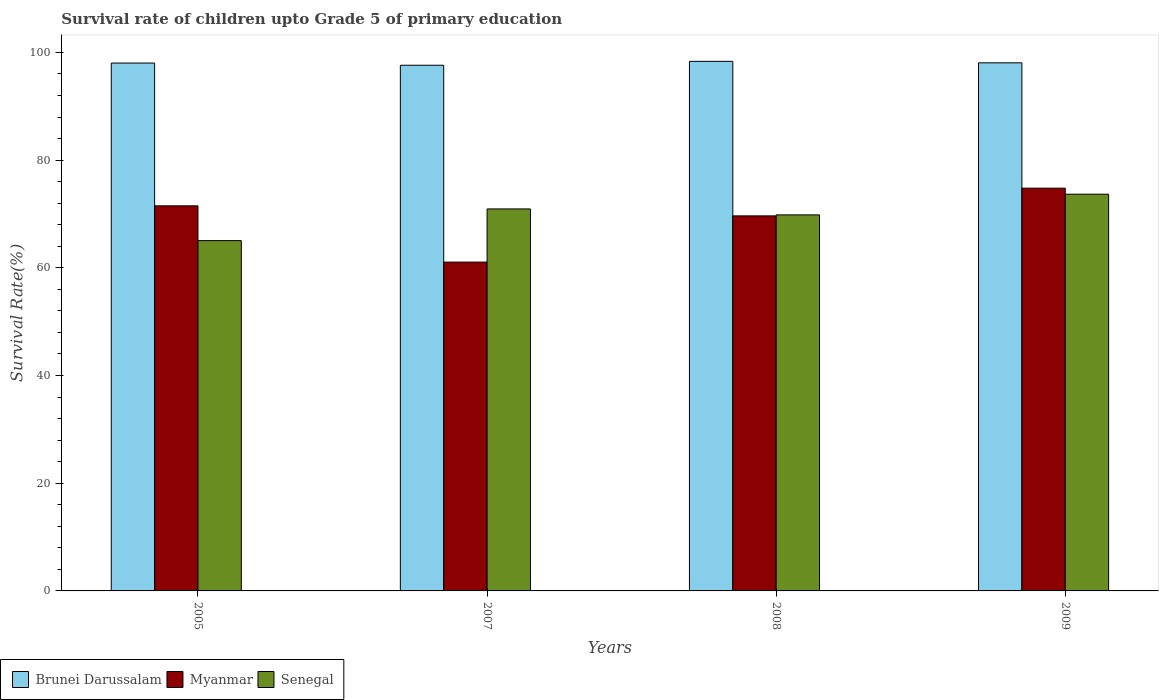How many groups of bars are there?
Offer a very short reply. 4. Are the number of bars per tick equal to the number of legend labels?
Offer a terse response. Yes. Are the number of bars on each tick of the X-axis equal?
Offer a very short reply. Yes. How many bars are there on the 2nd tick from the right?
Your answer should be very brief. 3. What is the label of the 1st group of bars from the left?
Offer a very short reply. 2005. What is the survival rate of children in Brunei Darussalam in 2007?
Ensure brevity in your answer.  97.62. Across all years, what is the maximum survival rate of children in Myanmar?
Ensure brevity in your answer.  74.79. Across all years, what is the minimum survival rate of children in Myanmar?
Make the answer very short. 61.06. In which year was the survival rate of children in Senegal maximum?
Provide a succinct answer. 2009. What is the total survival rate of children in Myanmar in the graph?
Keep it short and to the point. 277.01. What is the difference between the survival rate of children in Myanmar in 2008 and that in 2009?
Your response must be concise. -5.15. What is the difference between the survival rate of children in Brunei Darussalam in 2007 and the survival rate of children in Myanmar in 2005?
Provide a short and direct response. 26.11. What is the average survival rate of children in Senegal per year?
Provide a short and direct response. 69.87. In the year 2005, what is the difference between the survival rate of children in Senegal and survival rate of children in Myanmar?
Ensure brevity in your answer.  -6.46. In how many years, is the survival rate of children in Myanmar greater than 40 %?
Offer a terse response. 4. What is the ratio of the survival rate of children in Myanmar in 2007 to that in 2008?
Make the answer very short. 0.88. Is the survival rate of children in Myanmar in 2008 less than that in 2009?
Provide a short and direct response. Yes. What is the difference between the highest and the second highest survival rate of children in Brunei Darussalam?
Ensure brevity in your answer.  0.27. What is the difference between the highest and the lowest survival rate of children in Senegal?
Provide a short and direct response. 8.62. Is the sum of the survival rate of children in Brunei Darussalam in 2005 and 2009 greater than the maximum survival rate of children in Myanmar across all years?
Offer a very short reply. Yes. What does the 1st bar from the left in 2007 represents?
Provide a short and direct response. Brunei Darussalam. What does the 2nd bar from the right in 2008 represents?
Your answer should be very brief. Myanmar. Does the graph contain any zero values?
Provide a succinct answer. No. Does the graph contain grids?
Your answer should be compact. No. How are the legend labels stacked?
Provide a short and direct response. Horizontal. What is the title of the graph?
Keep it short and to the point. Survival rate of children upto Grade 5 of primary education. Does "Northern Mariana Islands" appear as one of the legend labels in the graph?
Your answer should be very brief. No. What is the label or title of the Y-axis?
Your answer should be compact. Survival Rate(%). What is the Survival Rate(%) of Brunei Darussalam in 2005?
Provide a succinct answer. 98.03. What is the Survival Rate(%) in Myanmar in 2005?
Provide a succinct answer. 71.51. What is the Survival Rate(%) in Senegal in 2005?
Keep it short and to the point. 65.05. What is the Survival Rate(%) of Brunei Darussalam in 2007?
Your answer should be very brief. 97.62. What is the Survival Rate(%) in Myanmar in 2007?
Your answer should be compact. 61.06. What is the Survival Rate(%) of Senegal in 2007?
Make the answer very short. 70.94. What is the Survival Rate(%) in Brunei Darussalam in 2008?
Your answer should be compact. 98.34. What is the Survival Rate(%) in Myanmar in 2008?
Ensure brevity in your answer.  69.65. What is the Survival Rate(%) in Senegal in 2008?
Offer a terse response. 69.83. What is the Survival Rate(%) of Brunei Darussalam in 2009?
Provide a short and direct response. 98.07. What is the Survival Rate(%) of Myanmar in 2009?
Keep it short and to the point. 74.79. What is the Survival Rate(%) of Senegal in 2009?
Keep it short and to the point. 73.67. Across all years, what is the maximum Survival Rate(%) in Brunei Darussalam?
Your answer should be very brief. 98.34. Across all years, what is the maximum Survival Rate(%) of Myanmar?
Provide a succinct answer. 74.79. Across all years, what is the maximum Survival Rate(%) in Senegal?
Give a very brief answer. 73.67. Across all years, what is the minimum Survival Rate(%) in Brunei Darussalam?
Your answer should be compact. 97.62. Across all years, what is the minimum Survival Rate(%) of Myanmar?
Offer a terse response. 61.06. Across all years, what is the minimum Survival Rate(%) in Senegal?
Keep it short and to the point. 65.05. What is the total Survival Rate(%) in Brunei Darussalam in the graph?
Offer a very short reply. 392.05. What is the total Survival Rate(%) in Myanmar in the graph?
Your answer should be very brief. 277.01. What is the total Survival Rate(%) of Senegal in the graph?
Offer a very short reply. 279.49. What is the difference between the Survival Rate(%) of Brunei Darussalam in 2005 and that in 2007?
Ensure brevity in your answer.  0.41. What is the difference between the Survival Rate(%) in Myanmar in 2005 and that in 2007?
Keep it short and to the point. 10.45. What is the difference between the Survival Rate(%) in Senegal in 2005 and that in 2007?
Offer a terse response. -5.89. What is the difference between the Survival Rate(%) of Brunei Darussalam in 2005 and that in 2008?
Give a very brief answer. -0.32. What is the difference between the Survival Rate(%) of Myanmar in 2005 and that in 2008?
Ensure brevity in your answer.  1.86. What is the difference between the Survival Rate(%) of Senegal in 2005 and that in 2008?
Ensure brevity in your answer.  -4.78. What is the difference between the Survival Rate(%) of Brunei Darussalam in 2005 and that in 2009?
Make the answer very short. -0.04. What is the difference between the Survival Rate(%) of Myanmar in 2005 and that in 2009?
Offer a terse response. -3.28. What is the difference between the Survival Rate(%) in Senegal in 2005 and that in 2009?
Offer a terse response. -8.62. What is the difference between the Survival Rate(%) in Brunei Darussalam in 2007 and that in 2008?
Offer a very short reply. -0.72. What is the difference between the Survival Rate(%) in Myanmar in 2007 and that in 2008?
Give a very brief answer. -8.59. What is the difference between the Survival Rate(%) in Senegal in 2007 and that in 2008?
Offer a terse response. 1.11. What is the difference between the Survival Rate(%) of Brunei Darussalam in 2007 and that in 2009?
Ensure brevity in your answer.  -0.45. What is the difference between the Survival Rate(%) in Myanmar in 2007 and that in 2009?
Your answer should be very brief. -13.73. What is the difference between the Survival Rate(%) of Senegal in 2007 and that in 2009?
Your response must be concise. -2.74. What is the difference between the Survival Rate(%) of Brunei Darussalam in 2008 and that in 2009?
Make the answer very short. 0.27. What is the difference between the Survival Rate(%) in Myanmar in 2008 and that in 2009?
Your response must be concise. -5.15. What is the difference between the Survival Rate(%) in Senegal in 2008 and that in 2009?
Provide a succinct answer. -3.84. What is the difference between the Survival Rate(%) of Brunei Darussalam in 2005 and the Survival Rate(%) of Myanmar in 2007?
Ensure brevity in your answer.  36.96. What is the difference between the Survival Rate(%) of Brunei Darussalam in 2005 and the Survival Rate(%) of Senegal in 2007?
Make the answer very short. 27.09. What is the difference between the Survival Rate(%) of Myanmar in 2005 and the Survival Rate(%) of Senegal in 2007?
Provide a short and direct response. 0.57. What is the difference between the Survival Rate(%) in Brunei Darussalam in 2005 and the Survival Rate(%) in Myanmar in 2008?
Offer a terse response. 28.38. What is the difference between the Survival Rate(%) of Brunei Darussalam in 2005 and the Survival Rate(%) of Senegal in 2008?
Your answer should be very brief. 28.19. What is the difference between the Survival Rate(%) of Myanmar in 2005 and the Survival Rate(%) of Senegal in 2008?
Your answer should be compact. 1.68. What is the difference between the Survival Rate(%) of Brunei Darussalam in 2005 and the Survival Rate(%) of Myanmar in 2009?
Your answer should be very brief. 23.23. What is the difference between the Survival Rate(%) of Brunei Darussalam in 2005 and the Survival Rate(%) of Senegal in 2009?
Give a very brief answer. 24.35. What is the difference between the Survival Rate(%) in Myanmar in 2005 and the Survival Rate(%) in Senegal in 2009?
Your response must be concise. -2.16. What is the difference between the Survival Rate(%) in Brunei Darussalam in 2007 and the Survival Rate(%) in Myanmar in 2008?
Provide a short and direct response. 27.97. What is the difference between the Survival Rate(%) of Brunei Darussalam in 2007 and the Survival Rate(%) of Senegal in 2008?
Your answer should be compact. 27.79. What is the difference between the Survival Rate(%) in Myanmar in 2007 and the Survival Rate(%) in Senegal in 2008?
Your response must be concise. -8.77. What is the difference between the Survival Rate(%) of Brunei Darussalam in 2007 and the Survival Rate(%) of Myanmar in 2009?
Your response must be concise. 22.83. What is the difference between the Survival Rate(%) of Brunei Darussalam in 2007 and the Survival Rate(%) of Senegal in 2009?
Keep it short and to the point. 23.94. What is the difference between the Survival Rate(%) of Myanmar in 2007 and the Survival Rate(%) of Senegal in 2009?
Provide a short and direct response. -12.61. What is the difference between the Survival Rate(%) of Brunei Darussalam in 2008 and the Survival Rate(%) of Myanmar in 2009?
Keep it short and to the point. 23.55. What is the difference between the Survival Rate(%) in Brunei Darussalam in 2008 and the Survival Rate(%) in Senegal in 2009?
Provide a short and direct response. 24.67. What is the difference between the Survival Rate(%) in Myanmar in 2008 and the Survival Rate(%) in Senegal in 2009?
Give a very brief answer. -4.03. What is the average Survival Rate(%) in Brunei Darussalam per year?
Ensure brevity in your answer.  98.01. What is the average Survival Rate(%) in Myanmar per year?
Keep it short and to the point. 69.25. What is the average Survival Rate(%) of Senegal per year?
Give a very brief answer. 69.87. In the year 2005, what is the difference between the Survival Rate(%) in Brunei Darussalam and Survival Rate(%) in Myanmar?
Make the answer very short. 26.52. In the year 2005, what is the difference between the Survival Rate(%) in Brunei Darussalam and Survival Rate(%) in Senegal?
Your answer should be very brief. 32.97. In the year 2005, what is the difference between the Survival Rate(%) of Myanmar and Survival Rate(%) of Senegal?
Your answer should be compact. 6.46. In the year 2007, what is the difference between the Survival Rate(%) of Brunei Darussalam and Survival Rate(%) of Myanmar?
Provide a short and direct response. 36.56. In the year 2007, what is the difference between the Survival Rate(%) of Brunei Darussalam and Survival Rate(%) of Senegal?
Offer a very short reply. 26.68. In the year 2007, what is the difference between the Survival Rate(%) of Myanmar and Survival Rate(%) of Senegal?
Your answer should be very brief. -9.88. In the year 2008, what is the difference between the Survival Rate(%) of Brunei Darussalam and Survival Rate(%) of Myanmar?
Offer a very short reply. 28.7. In the year 2008, what is the difference between the Survival Rate(%) in Brunei Darussalam and Survival Rate(%) in Senegal?
Offer a terse response. 28.51. In the year 2008, what is the difference between the Survival Rate(%) in Myanmar and Survival Rate(%) in Senegal?
Provide a short and direct response. -0.18. In the year 2009, what is the difference between the Survival Rate(%) in Brunei Darussalam and Survival Rate(%) in Myanmar?
Offer a very short reply. 23.28. In the year 2009, what is the difference between the Survival Rate(%) of Brunei Darussalam and Survival Rate(%) of Senegal?
Keep it short and to the point. 24.39. In the year 2009, what is the difference between the Survival Rate(%) of Myanmar and Survival Rate(%) of Senegal?
Your response must be concise. 1.12. What is the ratio of the Survival Rate(%) of Brunei Darussalam in 2005 to that in 2007?
Give a very brief answer. 1. What is the ratio of the Survival Rate(%) in Myanmar in 2005 to that in 2007?
Provide a short and direct response. 1.17. What is the ratio of the Survival Rate(%) of Senegal in 2005 to that in 2007?
Give a very brief answer. 0.92. What is the ratio of the Survival Rate(%) of Myanmar in 2005 to that in 2008?
Offer a very short reply. 1.03. What is the ratio of the Survival Rate(%) of Senegal in 2005 to that in 2008?
Your answer should be compact. 0.93. What is the ratio of the Survival Rate(%) of Myanmar in 2005 to that in 2009?
Give a very brief answer. 0.96. What is the ratio of the Survival Rate(%) of Senegal in 2005 to that in 2009?
Give a very brief answer. 0.88. What is the ratio of the Survival Rate(%) of Myanmar in 2007 to that in 2008?
Offer a very short reply. 0.88. What is the ratio of the Survival Rate(%) in Senegal in 2007 to that in 2008?
Provide a short and direct response. 1.02. What is the ratio of the Survival Rate(%) of Myanmar in 2007 to that in 2009?
Your answer should be compact. 0.82. What is the ratio of the Survival Rate(%) in Senegal in 2007 to that in 2009?
Ensure brevity in your answer.  0.96. What is the ratio of the Survival Rate(%) of Brunei Darussalam in 2008 to that in 2009?
Make the answer very short. 1. What is the ratio of the Survival Rate(%) of Myanmar in 2008 to that in 2009?
Your answer should be very brief. 0.93. What is the ratio of the Survival Rate(%) of Senegal in 2008 to that in 2009?
Provide a succinct answer. 0.95. What is the difference between the highest and the second highest Survival Rate(%) in Brunei Darussalam?
Offer a terse response. 0.27. What is the difference between the highest and the second highest Survival Rate(%) of Myanmar?
Give a very brief answer. 3.28. What is the difference between the highest and the second highest Survival Rate(%) of Senegal?
Make the answer very short. 2.74. What is the difference between the highest and the lowest Survival Rate(%) of Brunei Darussalam?
Give a very brief answer. 0.72. What is the difference between the highest and the lowest Survival Rate(%) in Myanmar?
Give a very brief answer. 13.73. What is the difference between the highest and the lowest Survival Rate(%) in Senegal?
Offer a terse response. 8.62. 